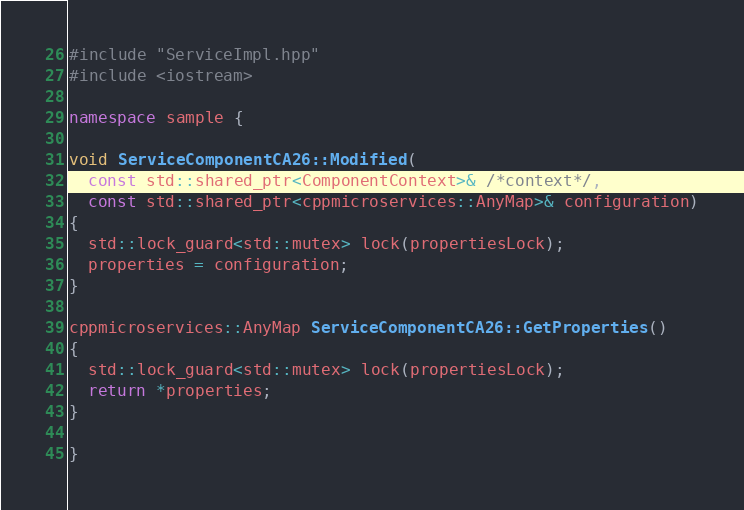Convert code to text. <code><loc_0><loc_0><loc_500><loc_500><_C++_>#include "ServiceImpl.hpp"
#include <iostream>

namespace sample {

void ServiceComponentCA26::Modified(
  const std::shared_ptr<ComponentContext>& /*context*/,
  const std::shared_ptr<cppmicroservices::AnyMap>& configuration)
{
  std::lock_guard<std::mutex> lock(propertiesLock);
  properties = configuration;
}

cppmicroservices::AnyMap ServiceComponentCA26::GetProperties()
{
  std::lock_guard<std::mutex> lock(propertiesLock);
  return *properties;
}

}
</code> 